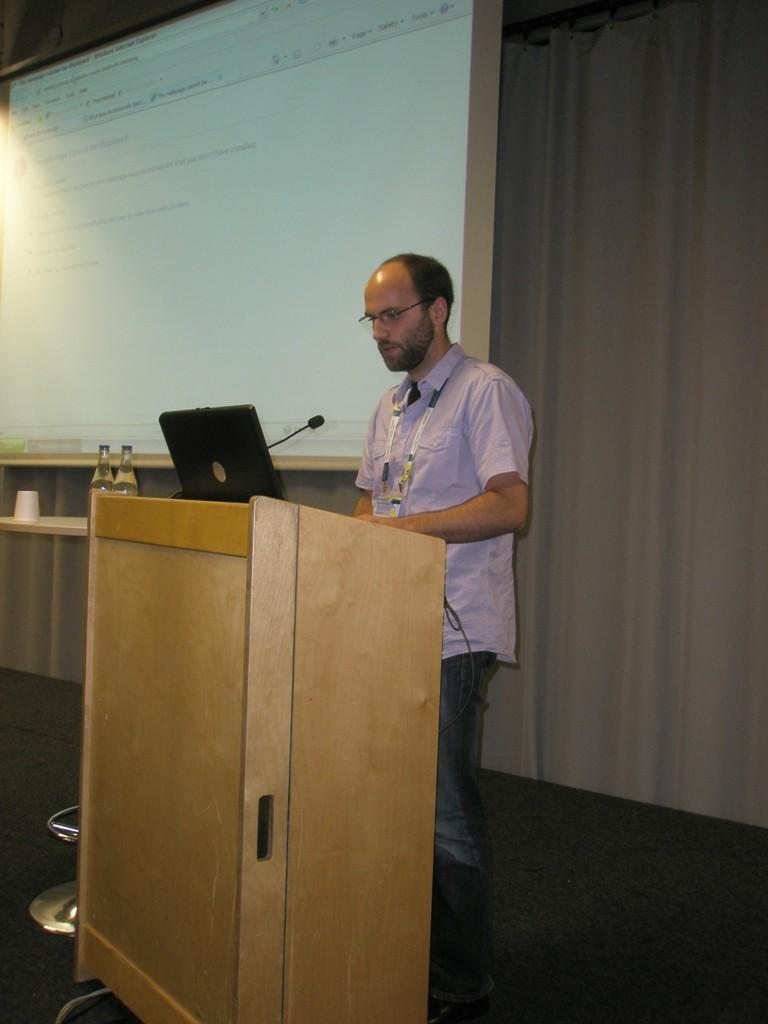Can you describe this image briefly? In this image a person is standing behind a podium which contains a laptop and a microphone, beside him water bottles and a cup is placed on a table and in the background there is a screen where some text is projected on it. 